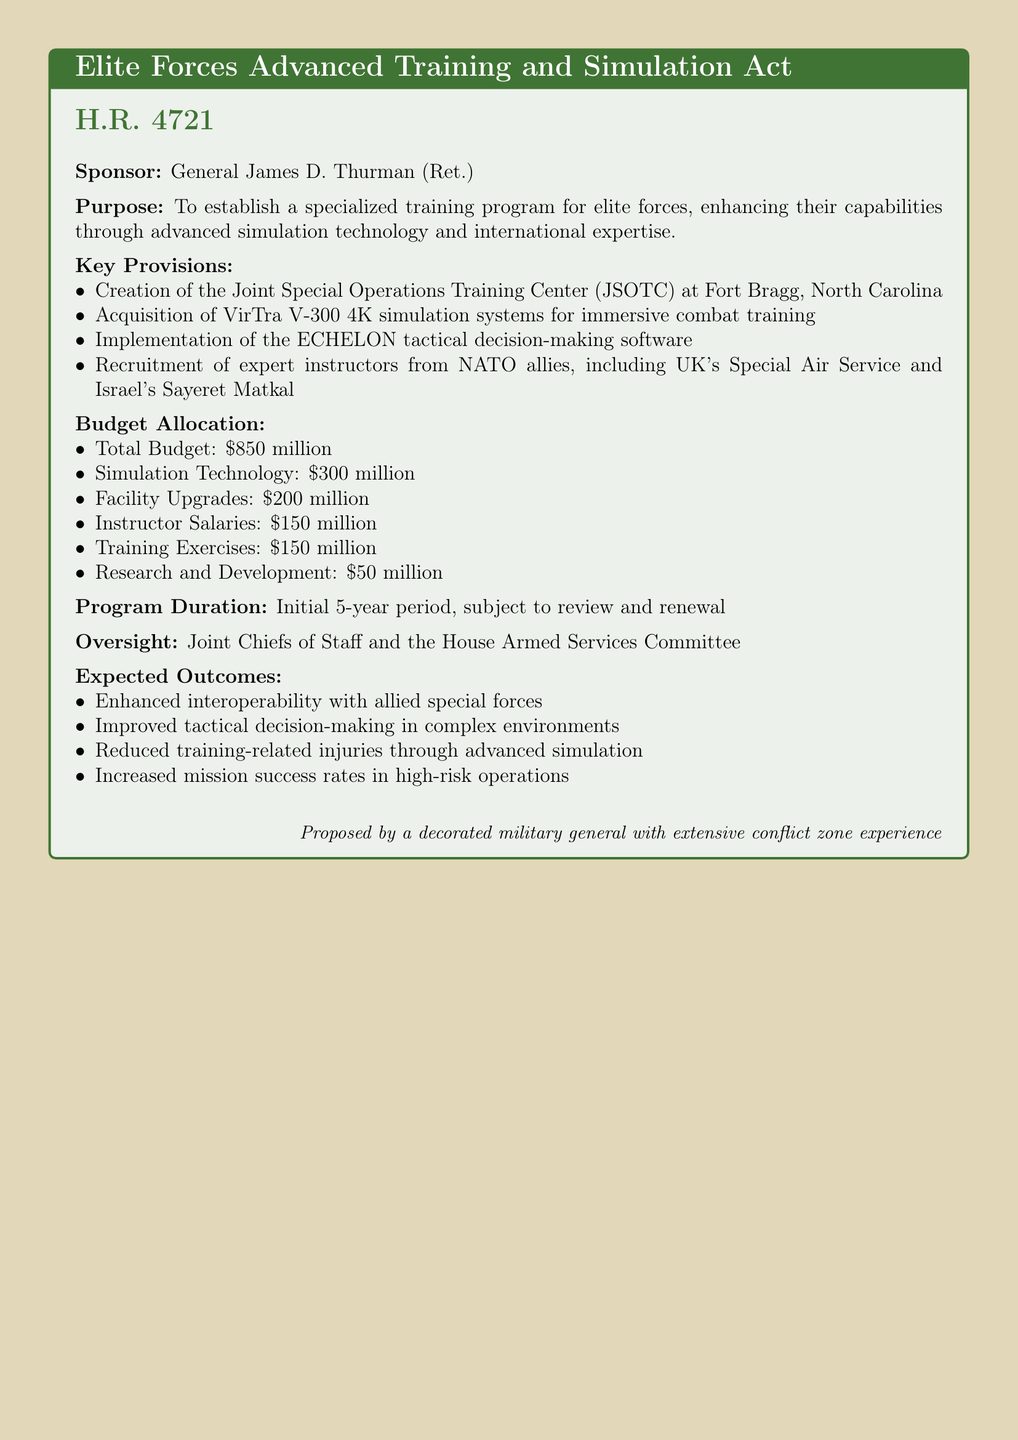what is the total budget allocated for the training program? The total budget allocated for the training program is explicitly stated in the document as $850 million.
Answer: $850 million who is the sponsor of the bill? The document clearly indicates that the sponsor of the bill is General James D. Thurman (Ret.).
Answer: General James D. Thurman (Ret.) where will the Joint Special Operations Training Center be established? The document specifies that the Joint Special Operations Training Center (JSOTC) will be established at Fort Bragg, North Carolina.
Answer: Fort Bragg, North Carolina which simulation system is mentioned in the bill? The bill refers to the acquisition of the VirTra V-300 4K simulation systems for immersive training.
Answer: VirTra V-300 4K how much is allocated for instructor salaries? The budget allocation specifies that $150 million is designated for instructor salaries.
Answer: $150 million what is the duration of the program? The document states that the initial duration of the program is set for five years, subject to review.
Answer: 5-year period which two special forces are mentioned for recruitment of expert instructors? The bill mentions recruiting instructors from the UK's Special Air Service and Israel's Sayeret Matkal.
Answer: UK's Special Air Service and Israel's Sayeret Matkal who will oversee the training program? The document indicates that the oversight will be managed by the Joint Chiefs of Staff and the House Armed Services Committee.
Answer: Joint Chiefs of Staff and the House Armed Services Committee 